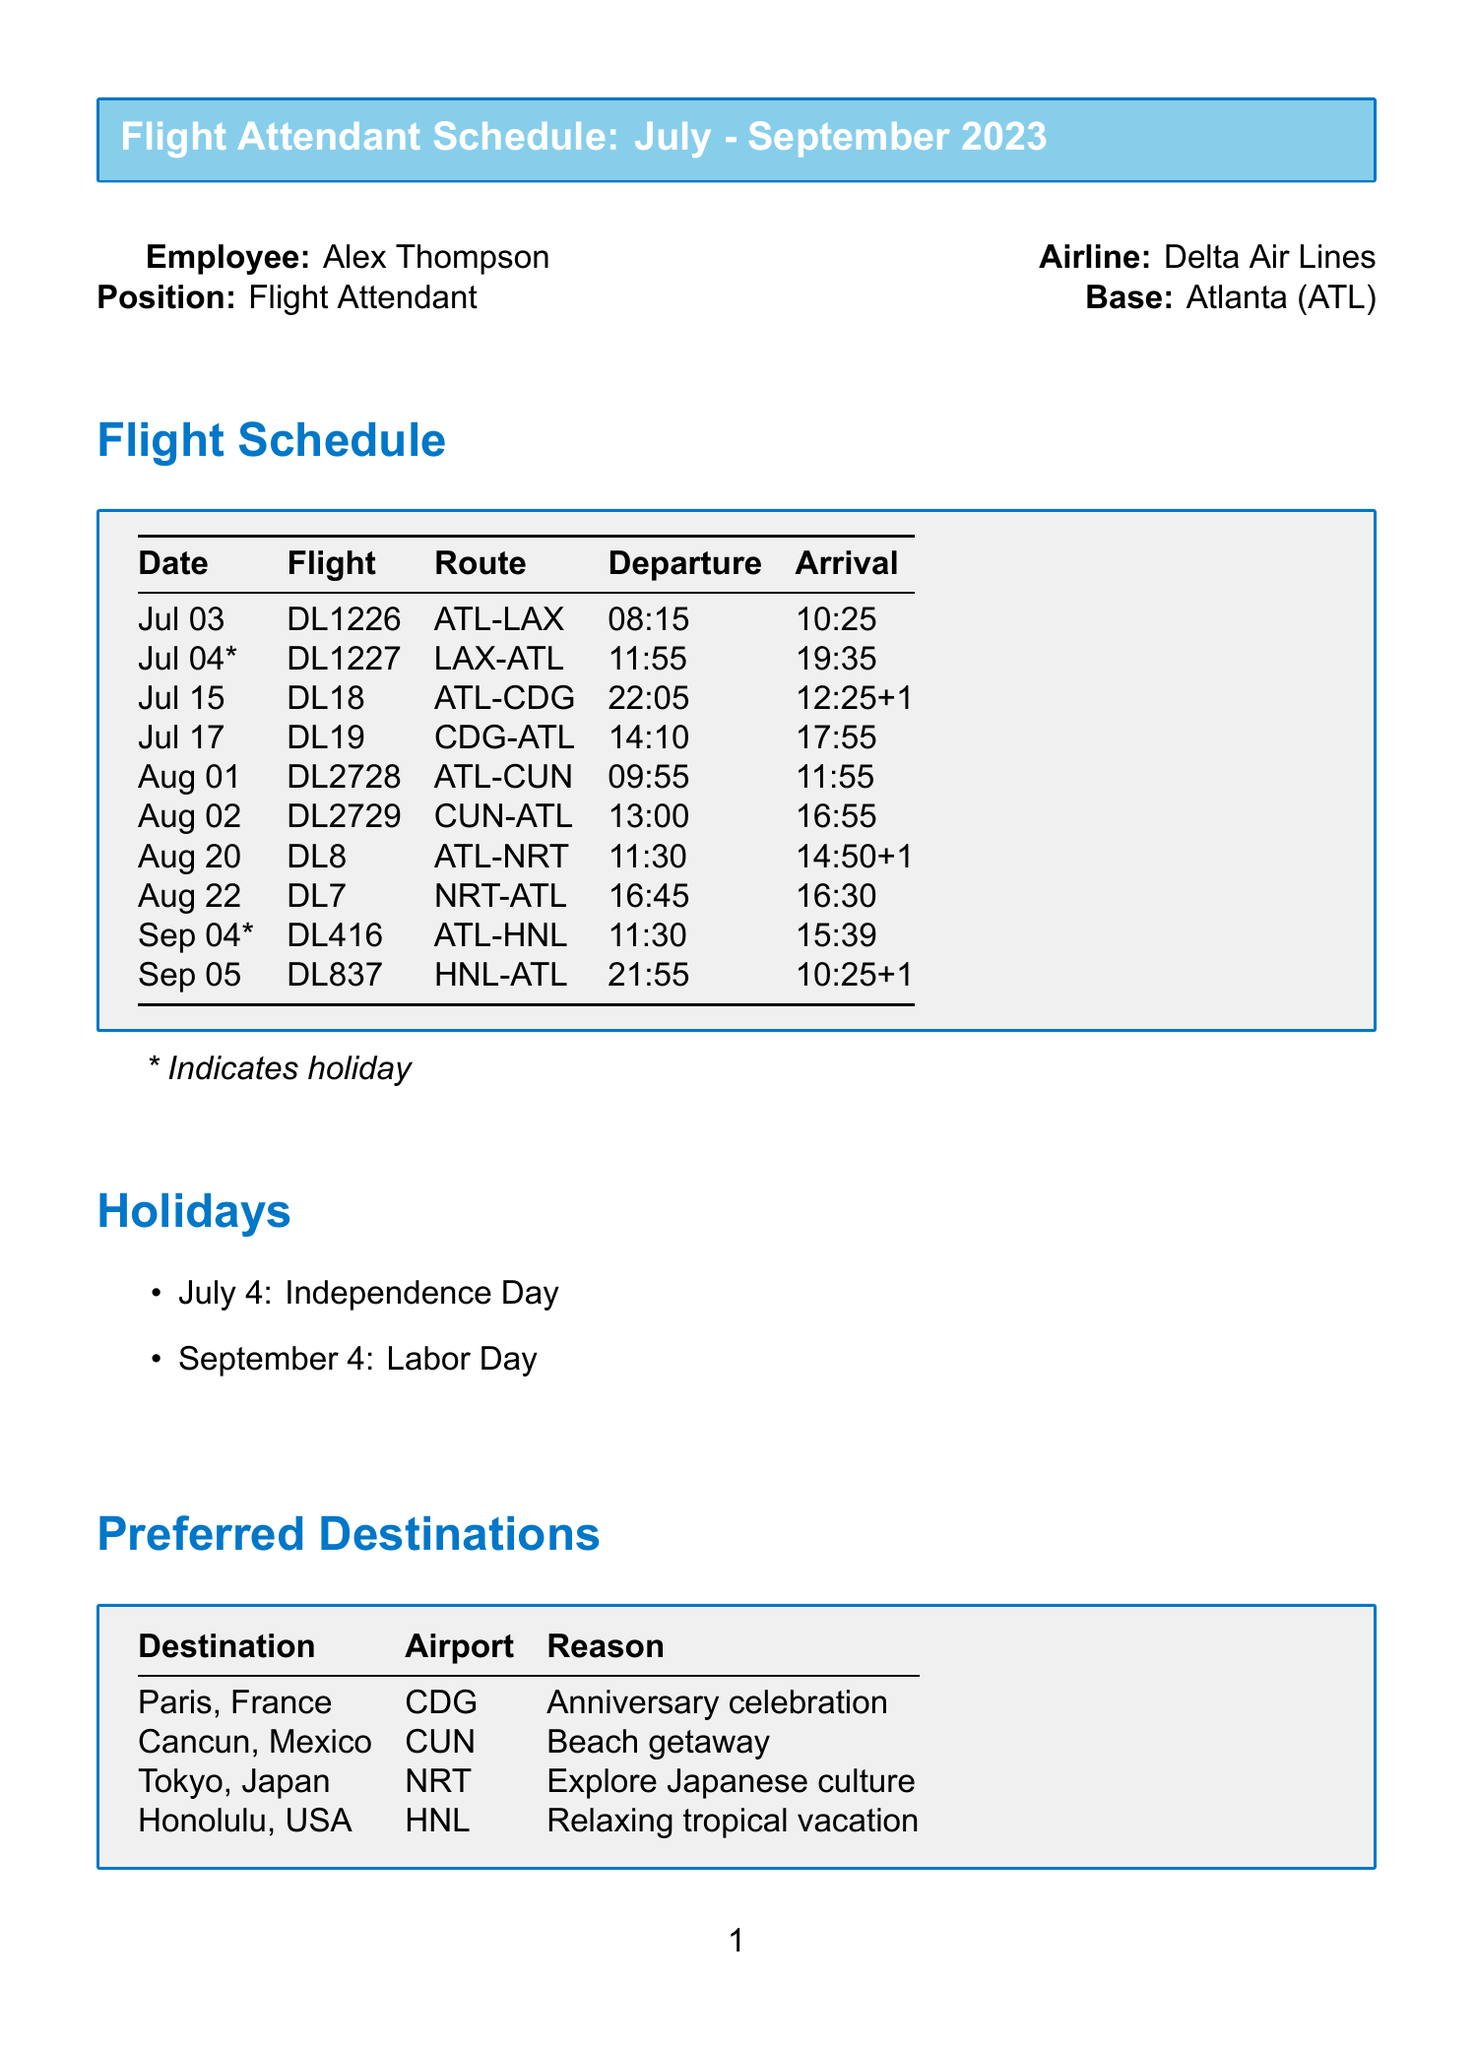What is the name of the employee? The employee's name is listed at the beginning of the document.
Answer: Alex Thompson What is the position of Alex Thompson? The document explicitly states the position of the employee.
Answer: Flight Attendant How many holidays are listed in the document? The document lists specific holidays in a dedicated section.
Answer: 2 What is the flight number for the flight on July 15? The flight number is specified in the flight schedule section for that date.
Answer: DL18 Which destination is associated with an anniversary celebration? The preferred destinations section provides specific reasons for each destination.
Answer: Paris, France On what date does the Labor Day holiday occur? The holiday information section provides specific dates for each holiday.
Answer: September 4 What airport code is used for Cancun? The airport code for Cancun is specified in the preferred destinations table.
Answer: CUN What is the discount offered by Marriott for hotel stays? Hotel discounts are provided in the partner travel benefits section.
Answer: 25% Which route does flight DL1226 take? The route for flight DL1226 is specified in the flight schedule section.
Answer: ATL-LAX 